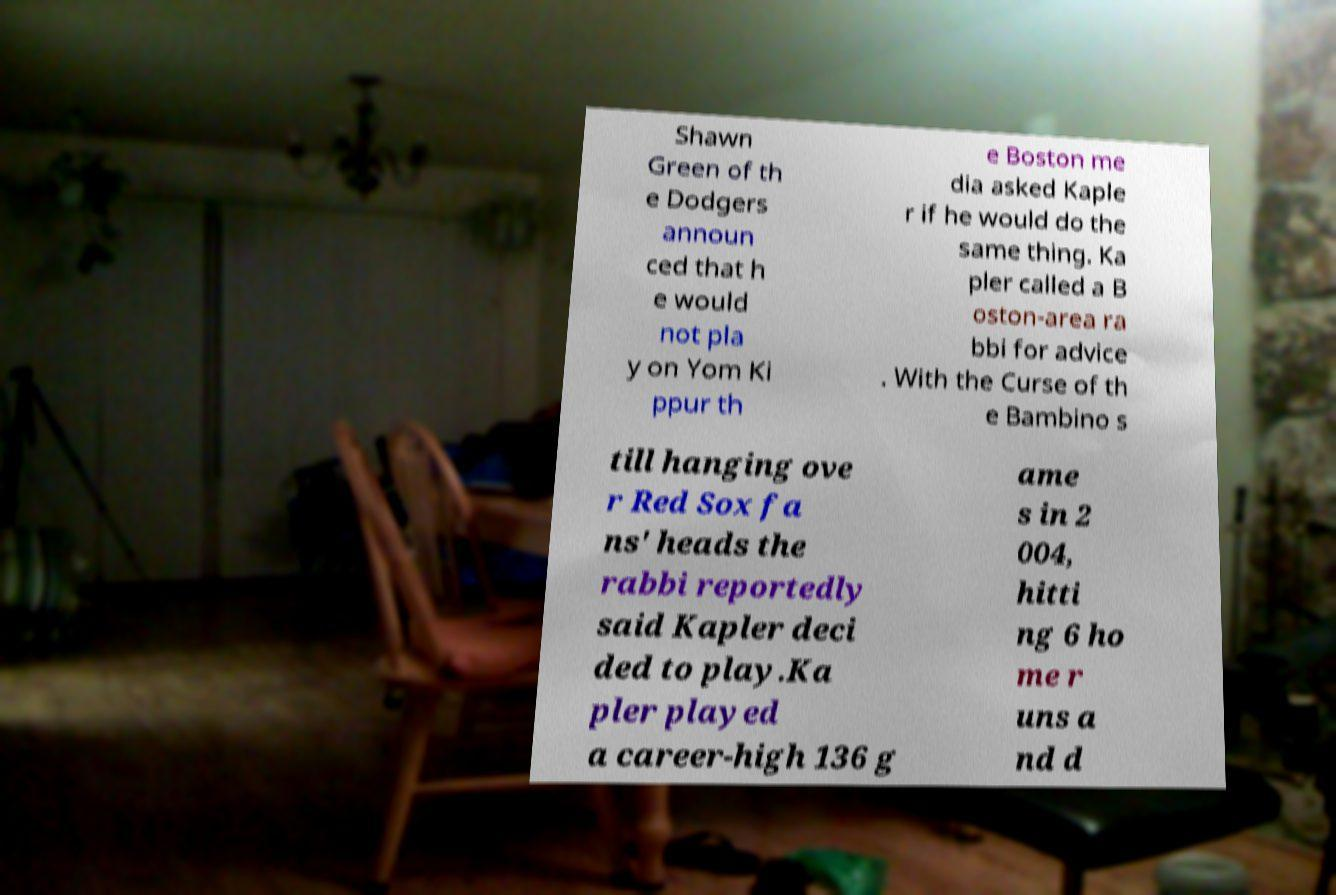Please read and relay the text visible in this image. What does it say? Shawn Green of th e Dodgers announ ced that h e would not pla y on Yom Ki ppur th e Boston me dia asked Kaple r if he would do the same thing. Ka pler called a B oston-area ra bbi for advice . With the Curse of th e Bambino s till hanging ove r Red Sox fa ns' heads the rabbi reportedly said Kapler deci ded to play.Ka pler played a career-high 136 g ame s in 2 004, hitti ng 6 ho me r uns a nd d 